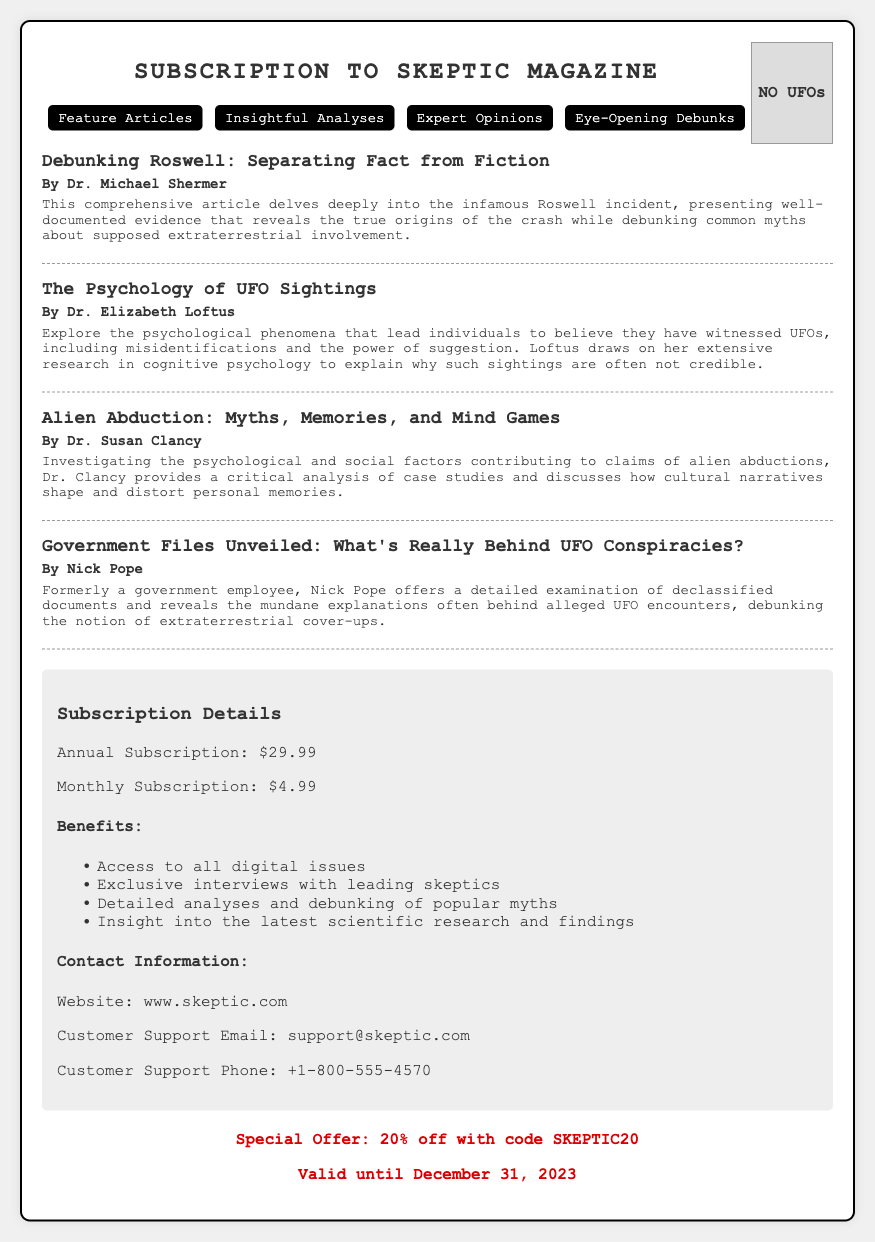What is the title of the magazine? The title of the magazine is prominently displayed at the top of the document, which is "Subscription to Skeptic Magazine."
Answer: Skeptic Magazine What is the annual subscription price? The document lists the annual subscription price under subscription details, which is $29.99.
Answer: $29.99 Who authored the article "The Psychology of UFO Sightings"? The authors of each article are mentioned below the titles; this article was authored by Dr. Elizabeth Loftus.
Answer: Dr. Elizabeth Loftus What special offer is mentioned in the document? The document states a special promotional offer for subscriptions which is 20% off with the code SKEPTIC20.
Answer: 20% off with code SKEPTIC20 What is the contact email for customer support? Customer support contact information is provided in the document, including the email, which is support@skeptic.com.
Answer: support@skeptic.com What psychological phenomena are discussed in one of the articles? The document highlights the psychological phenomena related to UFO sightings, such as misidentifications and the power of suggestion.
Answer: Misidentifications and the power of suggestion How many feature articles are listed? The document displays a list of articles under the "Feature Articles" header, specifically mentioning four articles.
Answer: Four Who is the author of "Government Files Unveiled"? The author of this article is mentioned as Nick Pope in the document.
Answer: Nick Pope What is the validity date of the special offer? The validity date of the special offer is noted in the promotional section stating it is valid until December 31, 2023.
Answer: December 31, 2023 